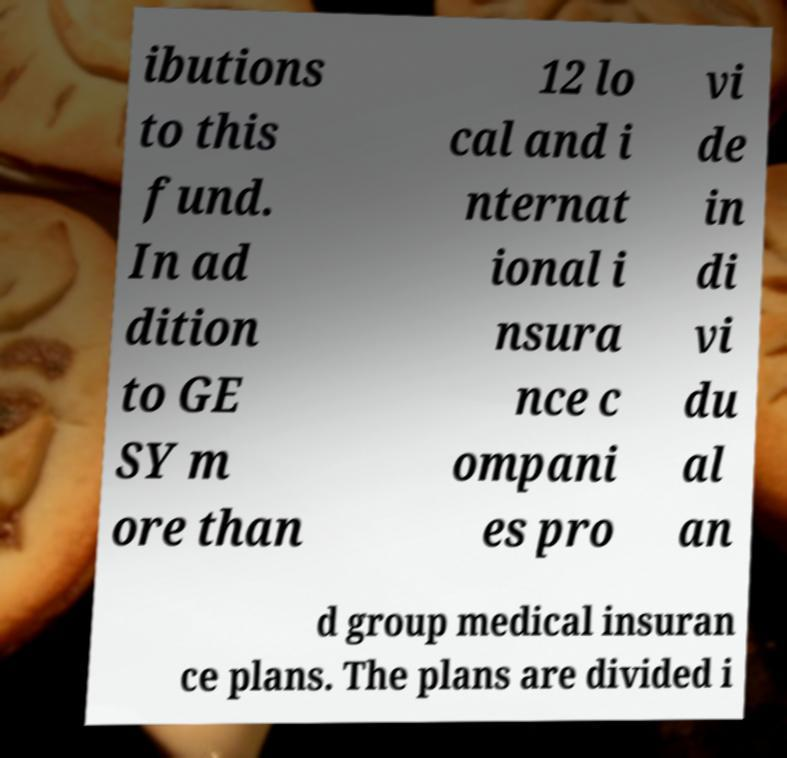Please identify and transcribe the text found in this image. ibutions to this fund. In ad dition to GE SY m ore than 12 lo cal and i nternat ional i nsura nce c ompani es pro vi de in di vi du al an d group medical insuran ce plans. The plans are divided i 